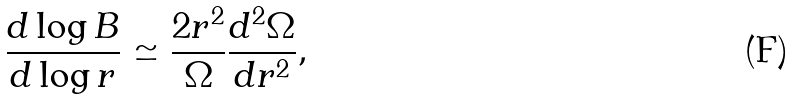Convert formula to latex. <formula><loc_0><loc_0><loc_500><loc_500>\frac { d \log B } { d \log r } \simeq \frac { 2 r ^ { 2 } } { \Omega } \frac { d ^ { 2 } \Omega } { d r ^ { 2 } } ,</formula> 